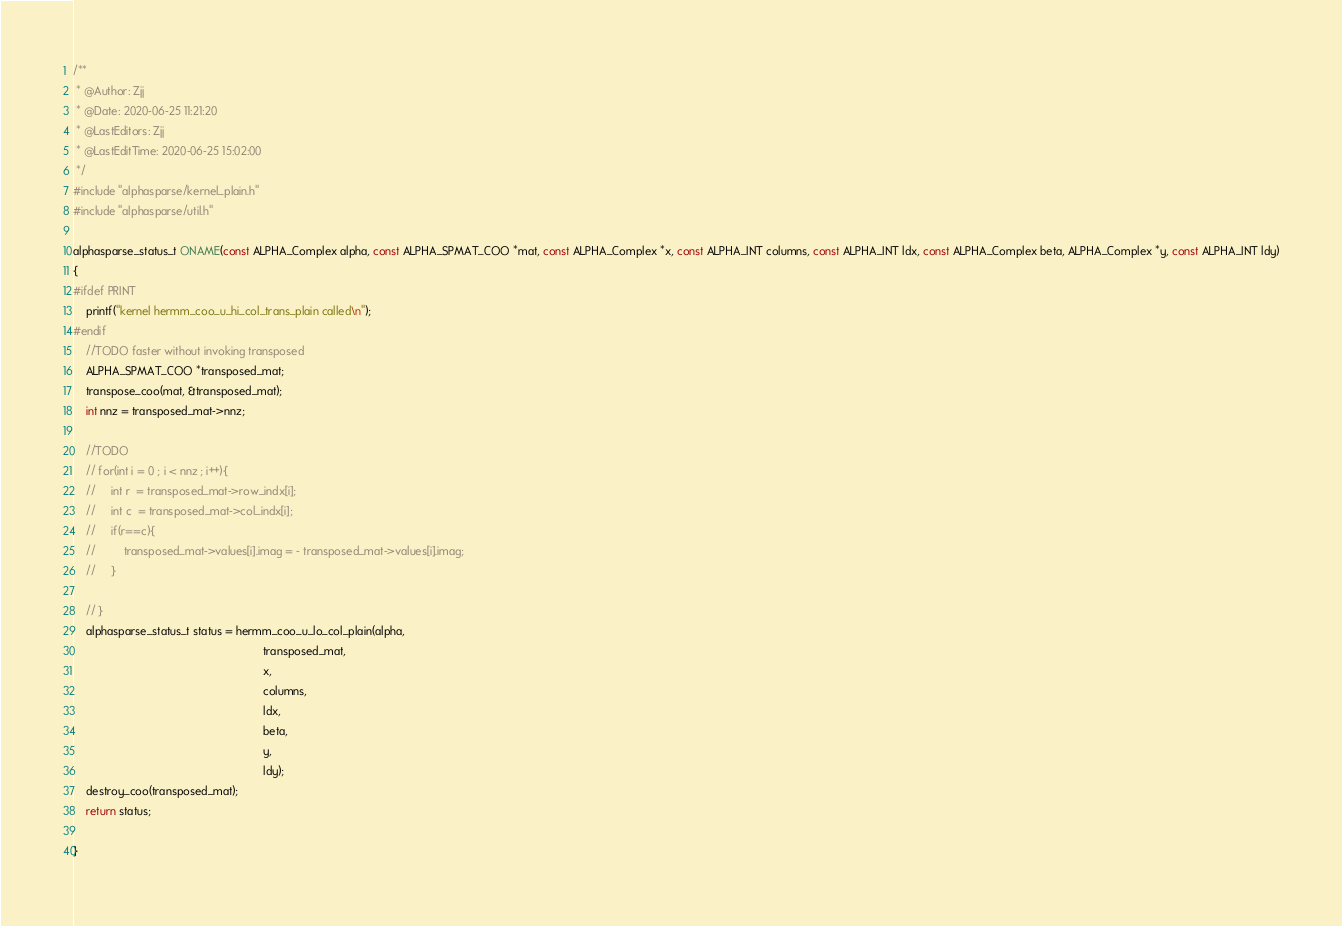<code> <loc_0><loc_0><loc_500><loc_500><_C_>/** 
 * @Author: Zjj
 * @Date: 2020-06-25 11:21:20
 * @LastEditors: Zjj
 * @LastEditTime: 2020-06-25 15:02:00
 */
#include "alphasparse/kernel_plain.h"
#include "alphasparse/util.h"

alphasparse_status_t ONAME(const ALPHA_Complex alpha, const ALPHA_SPMAT_COO *mat, const ALPHA_Complex *x, const ALPHA_INT columns, const ALPHA_INT ldx, const ALPHA_Complex beta, ALPHA_Complex *y, const ALPHA_INT ldy)
{
#ifdef PRINT
	printf("kernel hermm_coo_u_hi_col_trans_plain called\n");
#endif
    //TODO faster without invoking transposed 
    ALPHA_SPMAT_COO *transposed_mat;
    transpose_coo(mat, &transposed_mat);
    int nnz = transposed_mat->nnz;

    //TODO 
    // for(int i = 0 ; i < nnz ; i++){
    //     int r  = transposed_mat->row_indx[i];
    //     int c  = transposed_mat->col_indx[i];
    //     if(r==c){
    //         transposed_mat->values[i].imag = - transposed_mat->values[i].imag;
    //     }

    // }
    alphasparse_status_t status = hermm_coo_u_lo_col_plain(alpha,
		                                                    transposed_mat,
                                                            x,
                                                            columns,
                                                            ldx,
                                                            beta,
                                                            y,
                                                            ldy);
    destroy_coo(transposed_mat);
    return status;

}</code> 